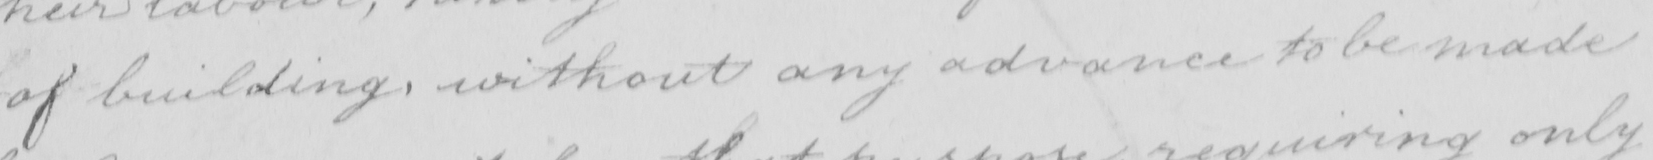Transcribe the text shown in this historical manuscript line. of building without any advance to be made 